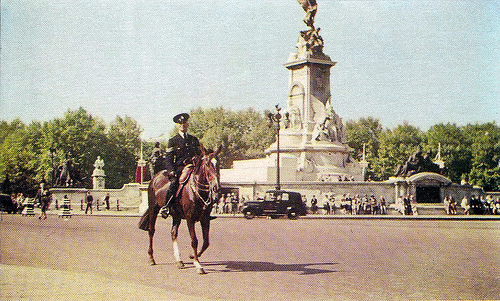How many people are running near a horse? Based on the image, there are no individuals that appear to be running near the horse. The picture shows a lone horse rider, likely a mounted police officer, who is calmly riding the horse, with various people in the distance, none of whom are running. 